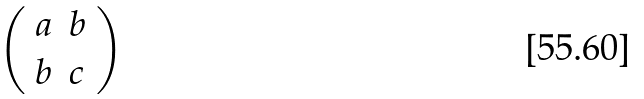Convert formula to latex. <formula><loc_0><loc_0><loc_500><loc_500>\left ( \begin{array} { l l } { a } & { b } \\ { b } & { c } \end{array} \right )</formula> 